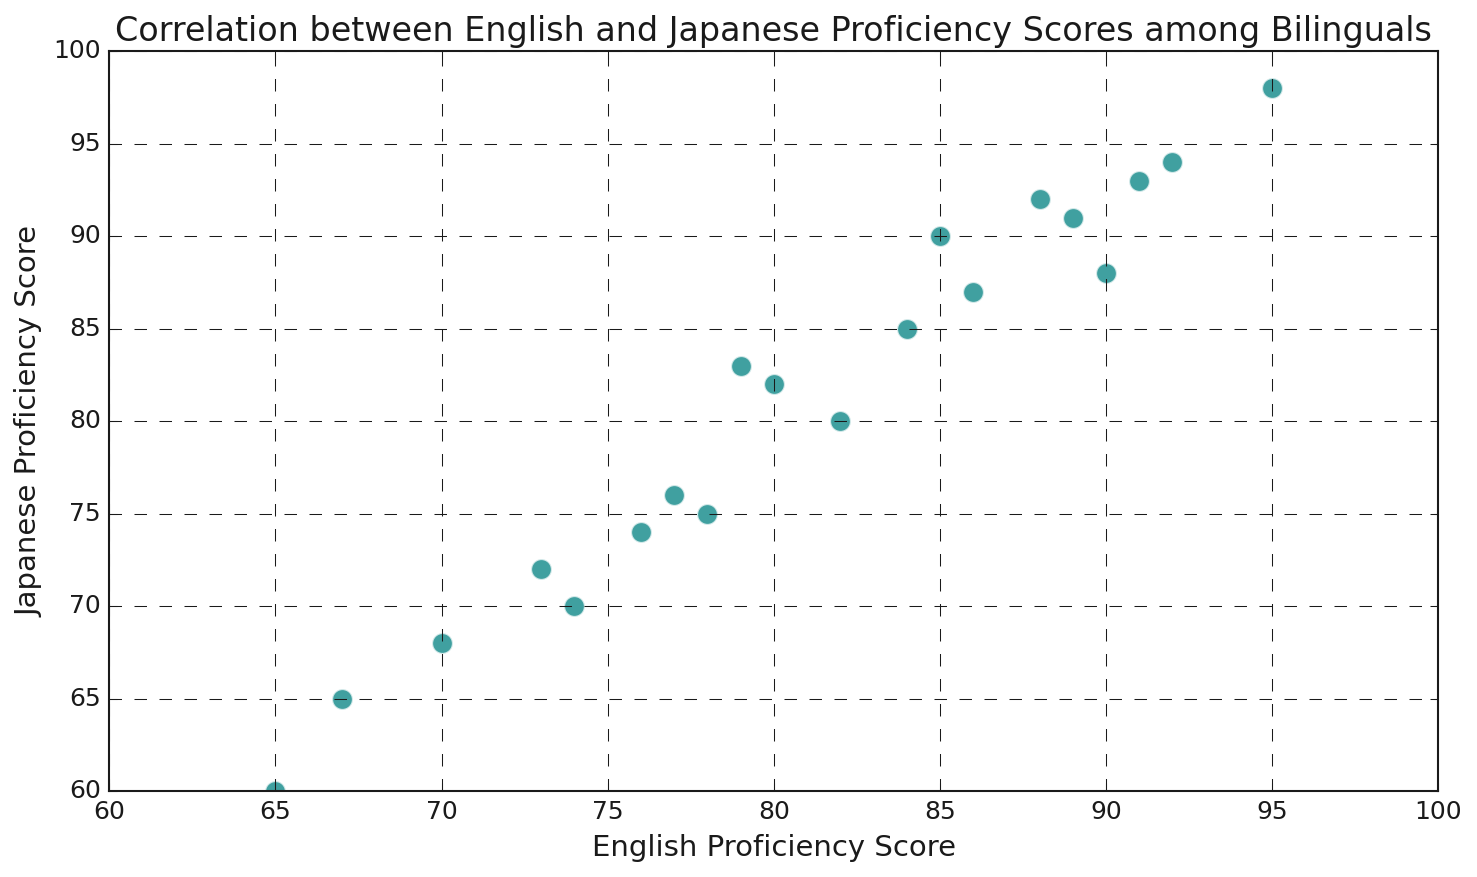What is the range of English Proficiency Scores displayed on the x-axis? To determine the range, observe the minimum and maximum values on the x-axis. The range appears to be from 60 to 100.
Answer: 60 to 100 Which proficiency score, English or Japanese, generally shows a higher range? Compare the range of scores on the x-axis (English, 60 to 100) and the y-axis (Japanese, 60 to 100). Both ranges are the same.
Answer: Equal What is the highest Japanese Proficiency Score shown on the plot? The highest point on the y-axis is identified. The point that reaches the highest value in Japanese Proficiency is near 98.
Answer: 98 Which proficiency score has a point with 95 English Proficiency? Identify the corresponding Japanese Proficiency value for the English Proficiency score of 95 by locating the point horizontally aligned with 95 on the x-axis. The score is 98.
Answer: 98 What is the average English Proficiency Score in the data? Sum all the English Proficiency scores and divide by the number of data points. (85 + 78 + 92 + 65 + 88 + 74 + 79 + 95 + 67 + 84 + 90 + 73 + 80 + 86 + 76 + 82 + 89 + 70 + 77 + 91) / 20 = 80.2.
Answer: 80.2 How many data points lie above the diagonal line where English Proficiency equals Japanese Proficiency? A point lies above the line if its Japanese Proficiency is higher than its English Proficiency. Counting the points fulfilling this criterion reveals 4 such points.
Answer: 4 What visual properties indicate the positions of the different proficiency scores on the plot? The positions are shown by points; teal markers with white edges, displayed on a grid with an overall range from 60 to 100 on each axis.
Answer: Teal points, white edges Is there a stronger visual indication of correlation between the scores, and what is it? By viewing the scatter plot, see if points align closely along a straight line from bottom-left to top-right, suggesting a positive correlation between English and Japanese scores. This visual pattern suggests a positive correlation.
Answer: Positive correlation Which pair of English and Japanese Proficiency scores is closest to the lower range of 60 on both axes? By finding the point closest to (60, 60). The point (65, 60) is closest.
Answer: 65 English, 60 Japanese What is the difference between the highest English Proficiency score and the lowest English Proficiency score? Subtract the lowest score from the highest score. Highest is 95, and lowest is 65. The difference is 95 - 65 = 30.
Answer: 30 